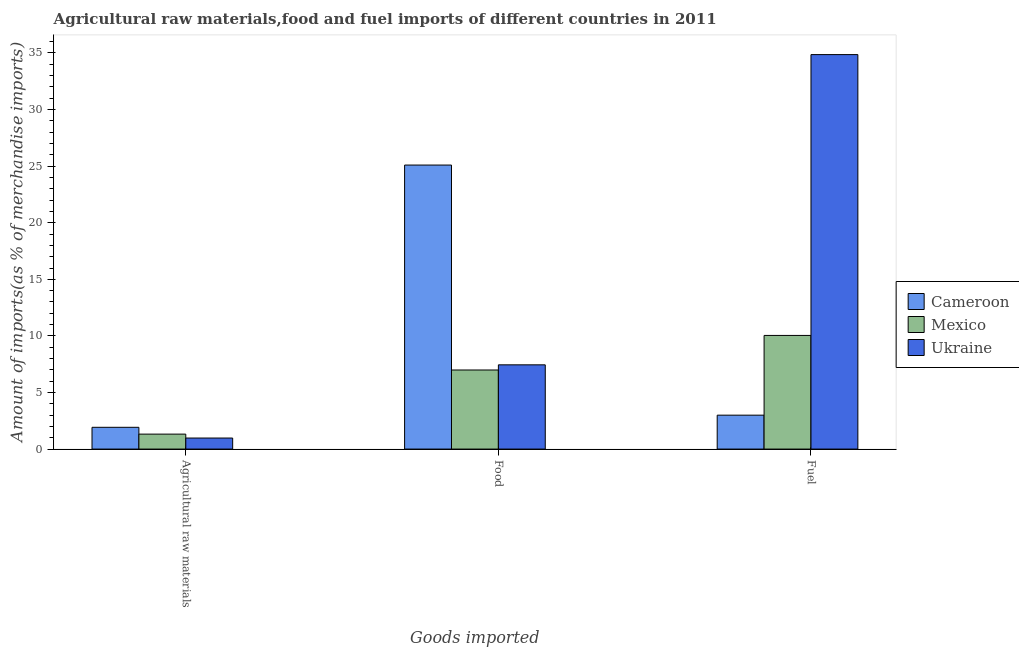Are the number of bars on each tick of the X-axis equal?
Your answer should be very brief. Yes. What is the label of the 2nd group of bars from the left?
Your answer should be compact. Food. What is the percentage of fuel imports in Mexico?
Offer a very short reply. 10.04. Across all countries, what is the maximum percentage of food imports?
Offer a terse response. 25.1. Across all countries, what is the minimum percentage of fuel imports?
Provide a short and direct response. 3. In which country was the percentage of fuel imports maximum?
Your answer should be compact. Ukraine. In which country was the percentage of raw materials imports minimum?
Ensure brevity in your answer.  Ukraine. What is the total percentage of raw materials imports in the graph?
Offer a terse response. 4.22. What is the difference between the percentage of raw materials imports in Mexico and that in Ukraine?
Offer a terse response. 0.35. What is the difference between the percentage of fuel imports in Cameroon and the percentage of food imports in Mexico?
Provide a succinct answer. -3.99. What is the average percentage of fuel imports per country?
Your answer should be compact. 15.97. What is the difference between the percentage of food imports and percentage of raw materials imports in Ukraine?
Your response must be concise. 6.47. In how many countries, is the percentage of fuel imports greater than 21 %?
Provide a short and direct response. 1. What is the ratio of the percentage of food imports in Ukraine to that in Cameroon?
Your response must be concise. 0.3. Is the difference between the percentage of raw materials imports in Cameroon and Ukraine greater than the difference between the percentage of food imports in Cameroon and Ukraine?
Offer a very short reply. No. What is the difference between the highest and the second highest percentage of fuel imports?
Make the answer very short. 24.81. What is the difference between the highest and the lowest percentage of raw materials imports?
Provide a succinct answer. 0.95. In how many countries, is the percentage of fuel imports greater than the average percentage of fuel imports taken over all countries?
Offer a very short reply. 1. Is the sum of the percentage of food imports in Ukraine and Cameroon greater than the maximum percentage of raw materials imports across all countries?
Your answer should be compact. Yes. What does the 1st bar from the left in Agricultural raw materials represents?
Your answer should be very brief. Cameroon. How many countries are there in the graph?
Keep it short and to the point. 3. What is the difference between two consecutive major ticks on the Y-axis?
Give a very brief answer. 5. Does the graph contain any zero values?
Provide a short and direct response. No. How are the legend labels stacked?
Your response must be concise. Vertical. What is the title of the graph?
Your response must be concise. Agricultural raw materials,food and fuel imports of different countries in 2011. Does "Tajikistan" appear as one of the legend labels in the graph?
Ensure brevity in your answer.  No. What is the label or title of the X-axis?
Keep it short and to the point. Goods imported. What is the label or title of the Y-axis?
Keep it short and to the point. Amount of imports(as % of merchandise imports). What is the Amount of imports(as % of merchandise imports) in Cameroon in Agricultural raw materials?
Your response must be concise. 1.92. What is the Amount of imports(as % of merchandise imports) of Mexico in Agricultural raw materials?
Provide a succinct answer. 1.32. What is the Amount of imports(as % of merchandise imports) in Ukraine in Agricultural raw materials?
Your response must be concise. 0.98. What is the Amount of imports(as % of merchandise imports) of Cameroon in Food?
Your answer should be very brief. 25.1. What is the Amount of imports(as % of merchandise imports) in Mexico in Food?
Your answer should be very brief. 6.99. What is the Amount of imports(as % of merchandise imports) of Ukraine in Food?
Make the answer very short. 7.44. What is the Amount of imports(as % of merchandise imports) in Cameroon in Fuel?
Your response must be concise. 3. What is the Amount of imports(as % of merchandise imports) of Mexico in Fuel?
Your answer should be compact. 10.04. What is the Amount of imports(as % of merchandise imports) of Ukraine in Fuel?
Offer a very short reply. 34.86. Across all Goods imported, what is the maximum Amount of imports(as % of merchandise imports) in Cameroon?
Provide a succinct answer. 25.1. Across all Goods imported, what is the maximum Amount of imports(as % of merchandise imports) in Mexico?
Keep it short and to the point. 10.04. Across all Goods imported, what is the maximum Amount of imports(as % of merchandise imports) in Ukraine?
Offer a very short reply. 34.86. Across all Goods imported, what is the minimum Amount of imports(as % of merchandise imports) in Cameroon?
Your answer should be compact. 1.92. Across all Goods imported, what is the minimum Amount of imports(as % of merchandise imports) of Mexico?
Give a very brief answer. 1.32. Across all Goods imported, what is the minimum Amount of imports(as % of merchandise imports) in Ukraine?
Offer a terse response. 0.98. What is the total Amount of imports(as % of merchandise imports) in Cameroon in the graph?
Ensure brevity in your answer.  30.02. What is the total Amount of imports(as % of merchandise imports) in Mexico in the graph?
Provide a succinct answer. 18.35. What is the total Amount of imports(as % of merchandise imports) of Ukraine in the graph?
Your response must be concise. 43.27. What is the difference between the Amount of imports(as % of merchandise imports) of Cameroon in Agricultural raw materials and that in Food?
Keep it short and to the point. -23.17. What is the difference between the Amount of imports(as % of merchandise imports) of Mexico in Agricultural raw materials and that in Food?
Make the answer very short. -5.67. What is the difference between the Amount of imports(as % of merchandise imports) of Ukraine in Agricultural raw materials and that in Food?
Make the answer very short. -6.47. What is the difference between the Amount of imports(as % of merchandise imports) in Cameroon in Agricultural raw materials and that in Fuel?
Your response must be concise. -1.07. What is the difference between the Amount of imports(as % of merchandise imports) of Mexico in Agricultural raw materials and that in Fuel?
Make the answer very short. -8.72. What is the difference between the Amount of imports(as % of merchandise imports) in Ukraine in Agricultural raw materials and that in Fuel?
Your response must be concise. -33.88. What is the difference between the Amount of imports(as % of merchandise imports) of Cameroon in Food and that in Fuel?
Provide a succinct answer. 22.1. What is the difference between the Amount of imports(as % of merchandise imports) of Mexico in Food and that in Fuel?
Your answer should be very brief. -3.05. What is the difference between the Amount of imports(as % of merchandise imports) of Ukraine in Food and that in Fuel?
Provide a short and direct response. -27.41. What is the difference between the Amount of imports(as % of merchandise imports) of Cameroon in Agricultural raw materials and the Amount of imports(as % of merchandise imports) of Mexico in Food?
Give a very brief answer. -5.06. What is the difference between the Amount of imports(as % of merchandise imports) in Cameroon in Agricultural raw materials and the Amount of imports(as % of merchandise imports) in Ukraine in Food?
Offer a terse response. -5.52. What is the difference between the Amount of imports(as % of merchandise imports) in Mexico in Agricultural raw materials and the Amount of imports(as % of merchandise imports) in Ukraine in Food?
Your answer should be compact. -6.12. What is the difference between the Amount of imports(as % of merchandise imports) of Cameroon in Agricultural raw materials and the Amount of imports(as % of merchandise imports) of Mexico in Fuel?
Provide a succinct answer. -8.12. What is the difference between the Amount of imports(as % of merchandise imports) of Cameroon in Agricultural raw materials and the Amount of imports(as % of merchandise imports) of Ukraine in Fuel?
Provide a succinct answer. -32.93. What is the difference between the Amount of imports(as % of merchandise imports) in Mexico in Agricultural raw materials and the Amount of imports(as % of merchandise imports) in Ukraine in Fuel?
Provide a short and direct response. -33.53. What is the difference between the Amount of imports(as % of merchandise imports) in Cameroon in Food and the Amount of imports(as % of merchandise imports) in Mexico in Fuel?
Your response must be concise. 15.05. What is the difference between the Amount of imports(as % of merchandise imports) in Cameroon in Food and the Amount of imports(as % of merchandise imports) in Ukraine in Fuel?
Your response must be concise. -9.76. What is the difference between the Amount of imports(as % of merchandise imports) in Mexico in Food and the Amount of imports(as % of merchandise imports) in Ukraine in Fuel?
Provide a succinct answer. -27.87. What is the average Amount of imports(as % of merchandise imports) in Cameroon per Goods imported?
Your response must be concise. 10.01. What is the average Amount of imports(as % of merchandise imports) in Mexico per Goods imported?
Provide a short and direct response. 6.12. What is the average Amount of imports(as % of merchandise imports) of Ukraine per Goods imported?
Make the answer very short. 14.43. What is the difference between the Amount of imports(as % of merchandise imports) of Cameroon and Amount of imports(as % of merchandise imports) of Mexico in Agricultural raw materials?
Offer a very short reply. 0.6. What is the difference between the Amount of imports(as % of merchandise imports) in Cameroon and Amount of imports(as % of merchandise imports) in Ukraine in Agricultural raw materials?
Ensure brevity in your answer.  0.95. What is the difference between the Amount of imports(as % of merchandise imports) of Mexico and Amount of imports(as % of merchandise imports) of Ukraine in Agricultural raw materials?
Provide a succinct answer. 0.35. What is the difference between the Amount of imports(as % of merchandise imports) in Cameroon and Amount of imports(as % of merchandise imports) in Mexico in Food?
Ensure brevity in your answer.  18.11. What is the difference between the Amount of imports(as % of merchandise imports) of Cameroon and Amount of imports(as % of merchandise imports) of Ukraine in Food?
Keep it short and to the point. 17.65. What is the difference between the Amount of imports(as % of merchandise imports) in Mexico and Amount of imports(as % of merchandise imports) in Ukraine in Food?
Provide a succinct answer. -0.46. What is the difference between the Amount of imports(as % of merchandise imports) in Cameroon and Amount of imports(as % of merchandise imports) in Mexico in Fuel?
Your answer should be compact. -7.05. What is the difference between the Amount of imports(as % of merchandise imports) in Cameroon and Amount of imports(as % of merchandise imports) in Ukraine in Fuel?
Your response must be concise. -31.86. What is the difference between the Amount of imports(as % of merchandise imports) of Mexico and Amount of imports(as % of merchandise imports) of Ukraine in Fuel?
Provide a short and direct response. -24.81. What is the ratio of the Amount of imports(as % of merchandise imports) in Cameroon in Agricultural raw materials to that in Food?
Make the answer very short. 0.08. What is the ratio of the Amount of imports(as % of merchandise imports) of Mexico in Agricultural raw materials to that in Food?
Make the answer very short. 0.19. What is the ratio of the Amount of imports(as % of merchandise imports) of Ukraine in Agricultural raw materials to that in Food?
Offer a very short reply. 0.13. What is the ratio of the Amount of imports(as % of merchandise imports) in Cameroon in Agricultural raw materials to that in Fuel?
Ensure brevity in your answer.  0.64. What is the ratio of the Amount of imports(as % of merchandise imports) of Mexico in Agricultural raw materials to that in Fuel?
Offer a very short reply. 0.13. What is the ratio of the Amount of imports(as % of merchandise imports) in Ukraine in Agricultural raw materials to that in Fuel?
Keep it short and to the point. 0.03. What is the ratio of the Amount of imports(as % of merchandise imports) of Cameroon in Food to that in Fuel?
Provide a short and direct response. 8.37. What is the ratio of the Amount of imports(as % of merchandise imports) of Mexico in Food to that in Fuel?
Offer a terse response. 0.7. What is the ratio of the Amount of imports(as % of merchandise imports) of Ukraine in Food to that in Fuel?
Your answer should be compact. 0.21. What is the difference between the highest and the second highest Amount of imports(as % of merchandise imports) of Cameroon?
Keep it short and to the point. 22.1. What is the difference between the highest and the second highest Amount of imports(as % of merchandise imports) in Mexico?
Offer a terse response. 3.05. What is the difference between the highest and the second highest Amount of imports(as % of merchandise imports) of Ukraine?
Provide a succinct answer. 27.41. What is the difference between the highest and the lowest Amount of imports(as % of merchandise imports) in Cameroon?
Give a very brief answer. 23.17. What is the difference between the highest and the lowest Amount of imports(as % of merchandise imports) in Mexico?
Keep it short and to the point. 8.72. What is the difference between the highest and the lowest Amount of imports(as % of merchandise imports) in Ukraine?
Give a very brief answer. 33.88. 